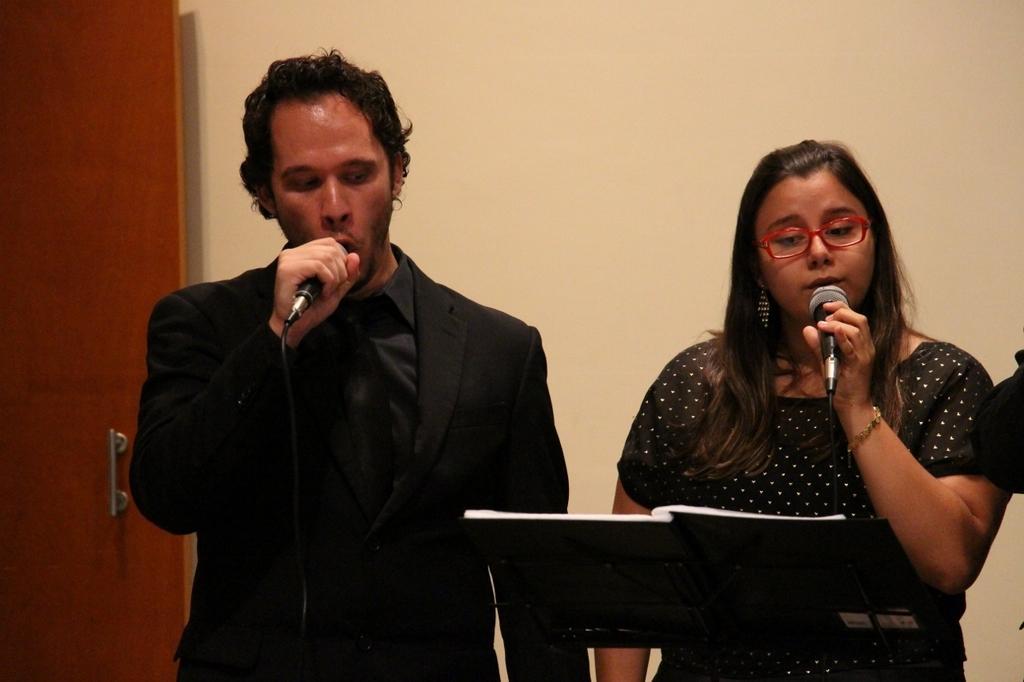In one or two sentences, can you explain what this image depicts? In this image I see a man and a woman who are holding mics and both of them are standing and there is stand on which there is a book on this and I can also see that these both are wearing black dresses. In the background I see the door and the wall. 